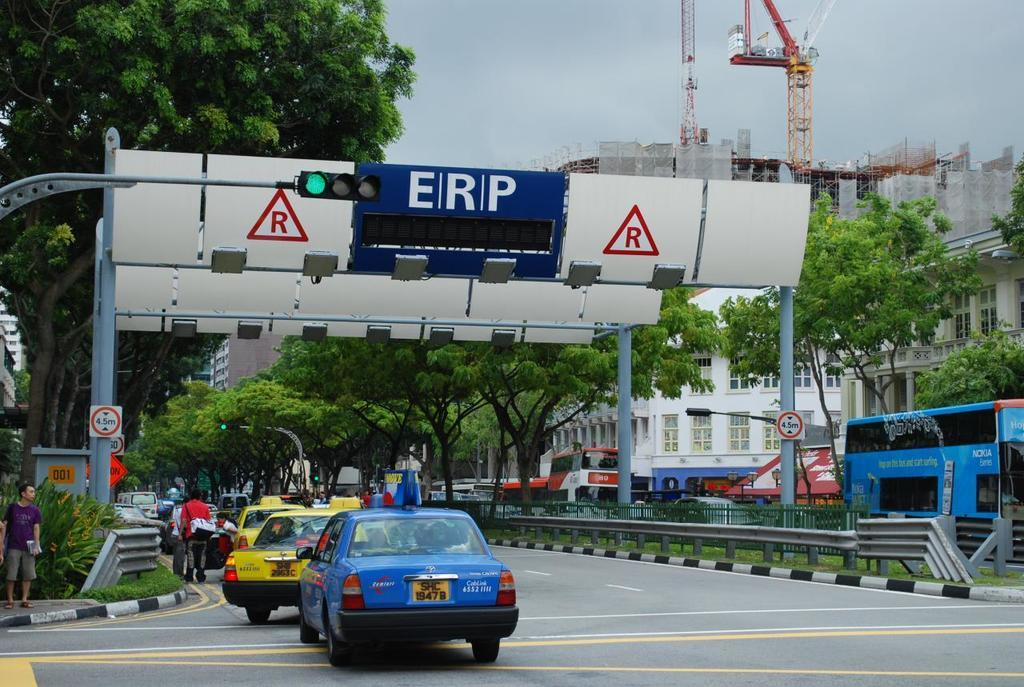Provide a one-sentence caption for the provided image. A white sign that is behind the stop light and says ERP. 